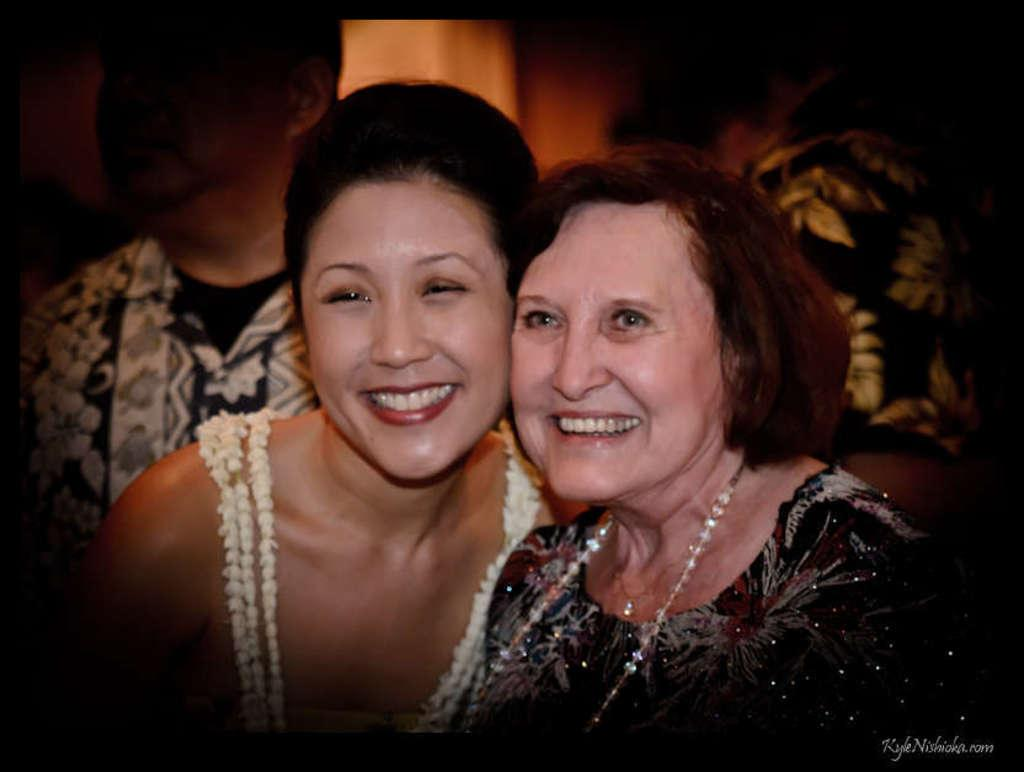How many women are in the image? There are two women in the image. What expression do the women have? The women are smiling. Can you describe the people behind the women? There are two other people behind the women. What type of pencil can be seen in the image? There is no pencil present in the image. How many pipes are visible in the image? There are no pipes visible in the image. 